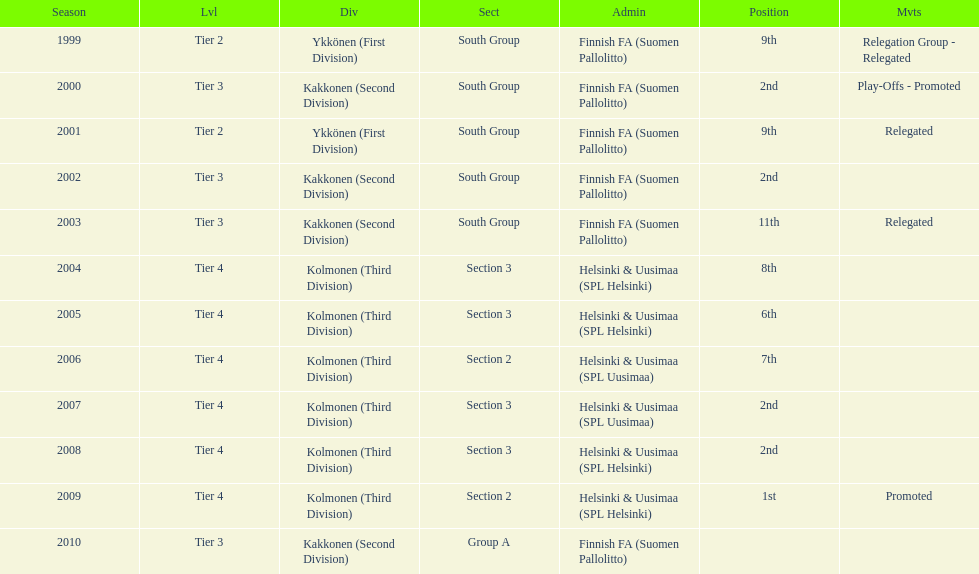How many second places were there? 4. 